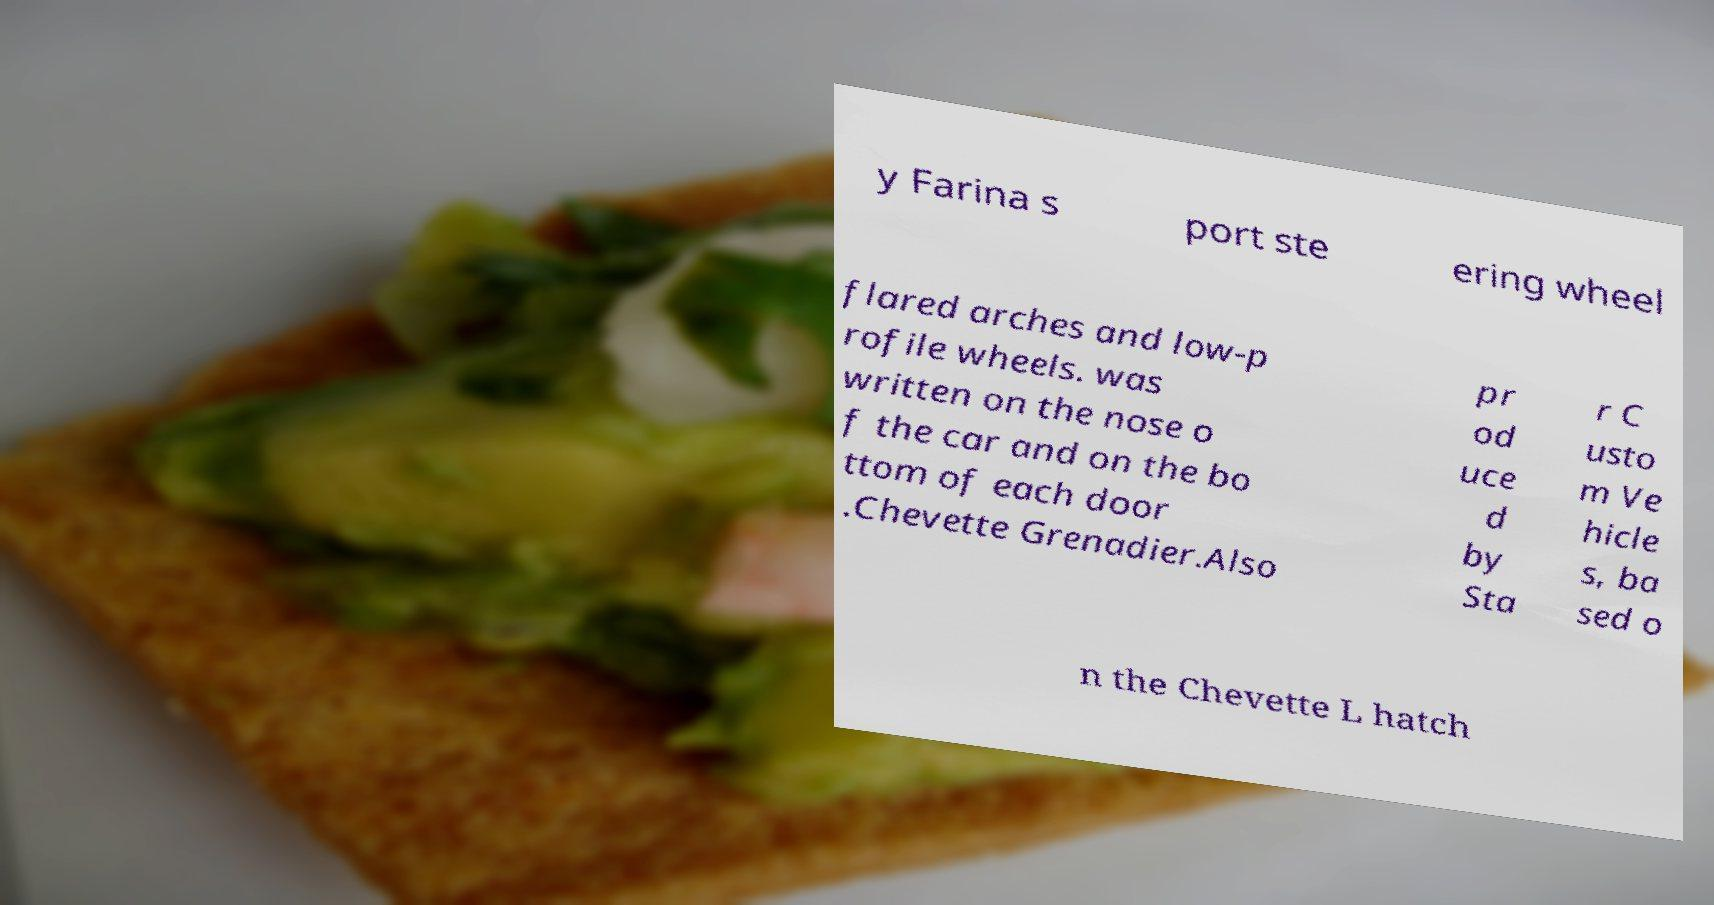Please identify and transcribe the text found in this image. y Farina s port ste ering wheel flared arches and low-p rofile wheels. was written on the nose o f the car and on the bo ttom of each door .Chevette Grenadier.Also pr od uce d by Sta r C usto m Ve hicle s, ba sed o n the Chevette L hatch 